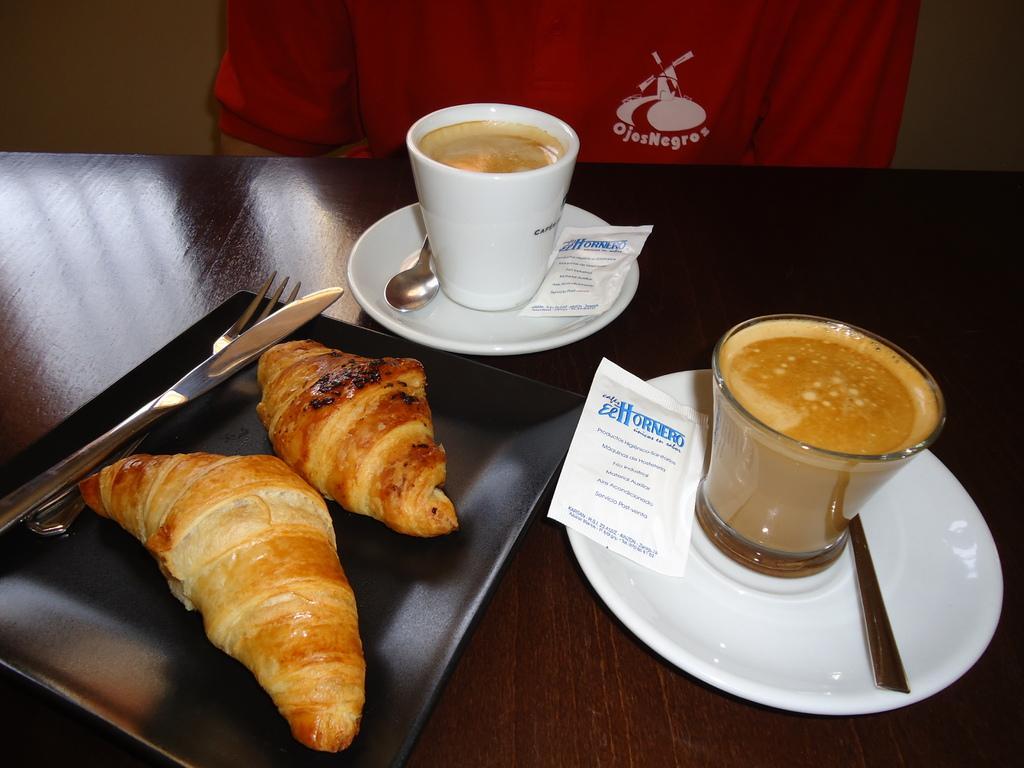Could you give a brief overview of what you see in this image? In this image, There is a table which is in brown color and there are some food items on the table and there some glasses and there is a person sitting on the chair around the table. 